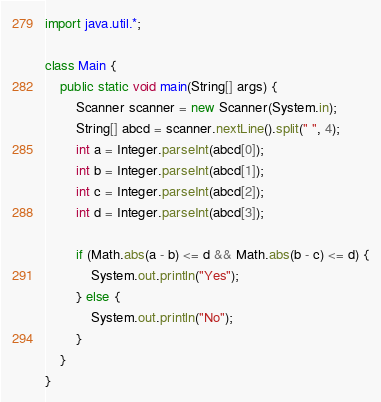Convert code to text. <code><loc_0><loc_0><loc_500><loc_500><_Java_>import java.util.*;

class Main {
    public static void main(String[] args) {
        Scanner scanner = new Scanner(System.in);
        String[] abcd = scanner.nextLine().split(" ", 4);
        int a = Integer.parseInt(abcd[0]);
        int b = Integer.parseInt(abcd[1]);
        int c = Integer.parseInt(abcd[2]);
        int d = Integer.parseInt(abcd[3]);

        if (Math.abs(a - b) <= d && Math.abs(b - c) <= d) {
            System.out.println("Yes");
        } else {
            System.out.println("No");
        }
    }
}</code> 